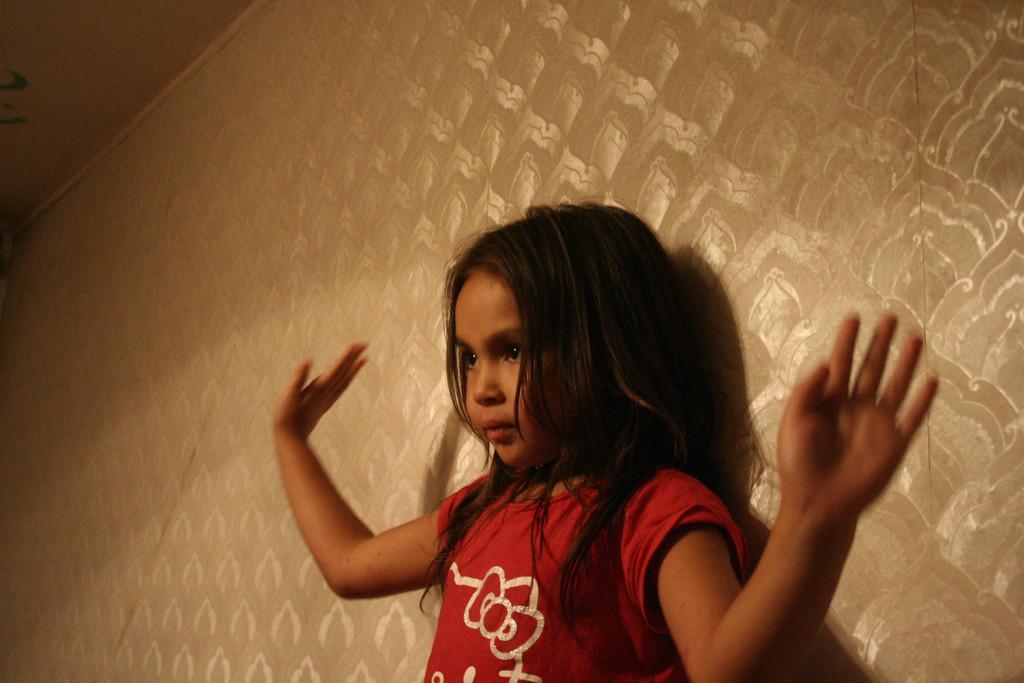Describe this image in one or two sentences. This image is taken indoors. In the background there is a wall. In the middle of the image there is a girl. At the top of the image there is a ceiling. 